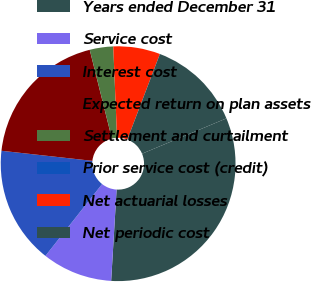Convert chart. <chart><loc_0><loc_0><loc_500><loc_500><pie_chart><fcel>Years ended December 31<fcel>Service cost<fcel>Interest cost<fcel>Expected return on plan assets<fcel>Settlement and curtailment<fcel>Prior service cost (credit)<fcel>Net actuarial losses<fcel>Net periodic cost<nl><fcel>32.26%<fcel>9.68%<fcel>16.13%<fcel>19.35%<fcel>3.23%<fcel>0.0%<fcel>6.45%<fcel>12.9%<nl></chart> 